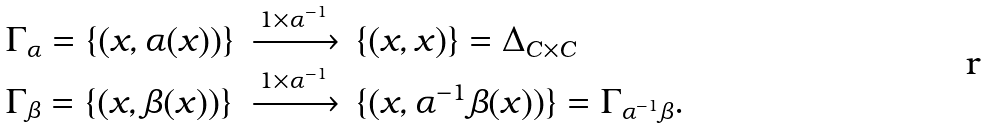Convert formula to latex. <formula><loc_0><loc_0><loc_500><loc_500>\begin{array} { l c l } \Gamma _ { \alpha } = \{ ( x , \alpha ( x ) ) \} & \xrightarrow { 1 \times \alpha ^ { - 1 } } & \{ ( x , x ) \} = \Delta _ { C \times C } \\ \Gamma _ { \beta } = \{ ( x , \beta ( x ) ) \} & \xrightarrow { 1 \times \alpha ^ { - 1 } } & \{ ( x , \alpha ^ { - 1 } \beta ( x ) ) \} = \Gamma _ { \alpha ^ { - 1 } \beta } . \end{array}</formula> 